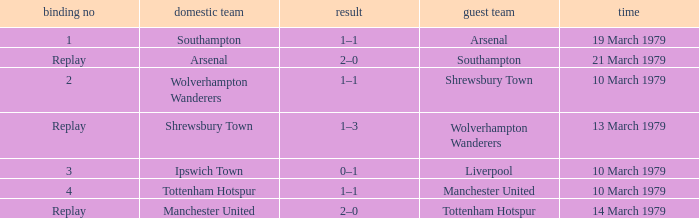Which tie number had an away team of Arsenal? 1.0. 